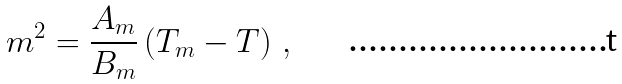Convert formula to latex. <formula><loc_0><loc_0><loc_500><loc_500>m ^ { 2 } = \frac { A _ { m } } { B _ { m } } \left ( T _ { m } - T \right ) \, ,</formula> 